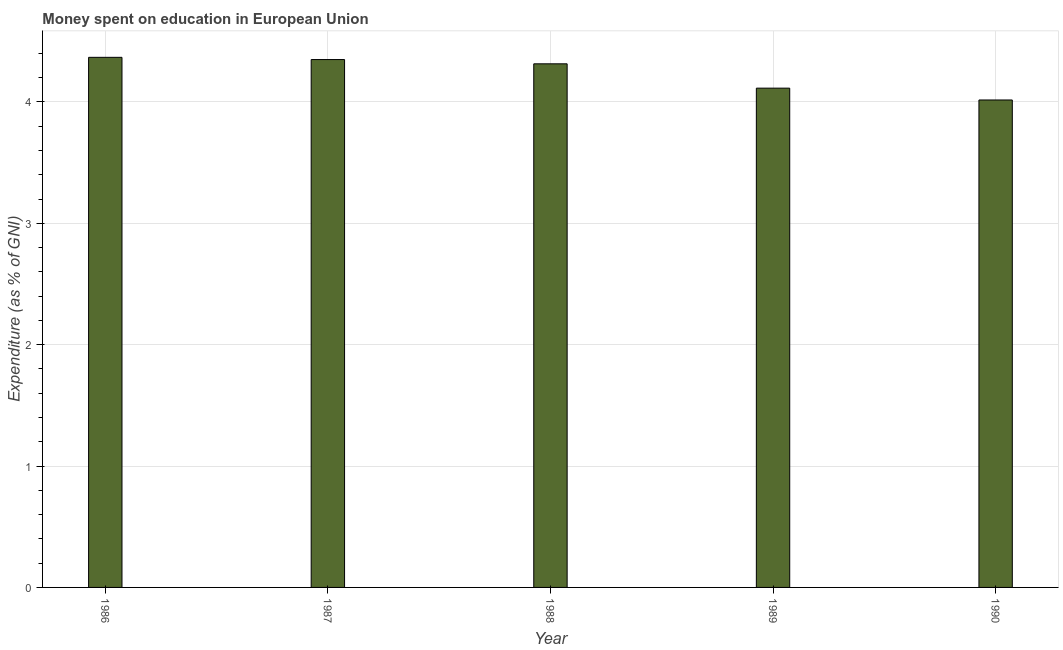Does the graph contain any zero values?
Ensure brevity in your answer.  No. Does the graph contain grids?
Give a very brief answer. Yes. What is the title of the graph?
Your answer should be compact. Money spent on education in European Union. What is the label or title of the Y-axis?
Provide a short and direct response. Expenditure (as % of GNI). What is the expenditure on education in 1987?
Keep it short and to the point. 4.35. Across all years, what is the maximum expenditure on education?
Provide a succinct answer. 4.37. Across all years, what is the minimum expenditure on education?
Your answer should be very brief. 4.02. In which year was the expenditure on education maximum?
Give a very brief answer. 1986. What is the sum of the expenditure on education?
Ensure brevity in your answer.  21.16. What is the difference between the expenditure on education in 1989 and 1990?
Provide a short and direct response. 0.1. What is the average expenditure on education per year?
Make the answer very short. 4.23. What is the median expenditure on education?
Give a very brief answer. 4.31. In how many years, is the expenditure on education greater than 1.6 %?
Your answer should be compact. 5. Do a majority of the years between 1986 and 1989 (inclusive) have expenditure on education greater than 0.6 %?
Your answer should be compact. Yes. What is the ratio of the expenditure on education in 1986 to that in 1989?
Provide a succinct answer. 1.06. Is the expenditure on education in 1987 less than that in 1990?
Ensure brevity in your answer.  No. Is the difference between the expenditure on education in 1987 and 1989 greater than the difference between any two years?
Your answer should be compact. No. What is the difference between the highest and the second highest expenditure on education?
Make the answer very short. 0.02. Is the sum of the expenditure on education in 1986 and 1989 greater than the maximum expenditure on education across all years?
Your answer should be compact. Yes. What is the difference between the highest and the lowest expenditure on education?
Keep it short and to the point. 0.35. In how many years, is the expenditure on education greater than the average expenditure on education taken over all years?
Ensure brevity in your answer.  3. How many years are there in the graph?
Ensure brevity in your answer.  5. What is the difference between two consecutive major ticks on the Y-axis?
Make the answer very short. 1. What is the Expenditure (as % of GNI) of 1986?
Make the answer very short. 4.37. What is the Expenditure (as % of GNI) of 1987?
Provide a succinct answer. 4.35. What is the Expenditure (as % of GNI) in 1988?
Offer a very short reply. 4.31. What is the Expenditure (as % of GNI) in 1989?
Your response must be concise. 4.11. What is the Expenditure (as % of GNI) of 1990?
Make the answer very short. 4.02. What is the difference between the Expenditure (as % of GNI) in 1986 and 1987?
Keep it short and to the point. 0.02. What is the difference between the Expenditure (as % of GNI) in 1986 and 1988?
Provide a short and direct response. 0.05. What is the difference between the Expenditure (as % of GNI) in 1986 and 1989?
Offer a terse response. 0.25. What is the difference between the Expenditure (as % of GNI) in 1986 and 1990?
Your answer should be compact. 0.35. What is the difference between the Expenditure (as % of GNI) in 1987 and 1988?
Make the answer very short. 0.04. What is the difference between the Expenditure (as % of GNI) in 1987 and 1989?
Provide a short and direct response. 0.24. What is the difference between the Expenditure (as % of GNI) in 1987 and 1990?
Ensure brevity in your answer.  0.33. What is the difference between the Expenditure (as % of GNI) in 1988 and 1989?
Offer a very short reply. 0.2. What is the difference between the Expenditure (as % of GNI) in 1988 and 1990?
Offer a terse response. 0.3. What is the difference between the Expenditure (as % of GNI) in 1989 and 1990?
Offer a terse response. 0.1. What is the ratio of the Expenditure (as % of GNI) in 1986 to that in 1987?
Provide a succinct answer. 1. What is the ratio of the Expenditure (as % of GNI) in 1986 to that in 1989?
Make the answer very short. 1.06. What is the ratio of the Expenditure (as % of GNI) in 1986 to that in 1990?
Your response must be concise. 1.09. What is the ratio of the Expenditure (as % of GNI) in 1987 to that in 1988?
Make the answer very short. 1.01. What is the ratio of the Expenditure (as % of GNI) in 1987 to that in 1989?
Offer a very short reply. 1.06. What is the ratio of the Expenditure (as % of GNI) in 1987 to that in 1990?
Offer a terse response. 1.08. What is the ratio of the Expenditure (as % of GNI) in 1988 to that in 1989?
Provide a short and direct response. 1.05. What is the ratio of the Expenditure (as % of GNI) in 1988 to that in 1990?
Offer a very short reply. 1.07. 